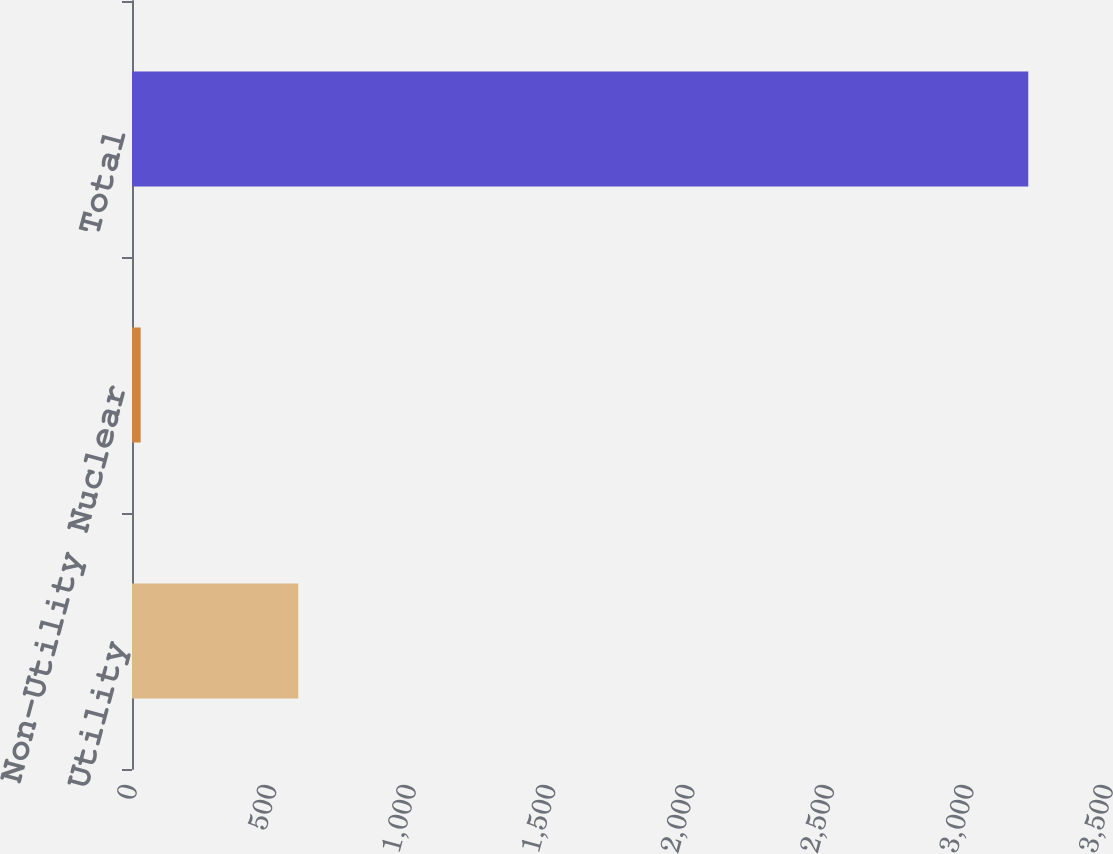Convert chart to OTSL. <chart><loc_0><loc_0><loc_500><loc_500><bar_chart><fcel>Utility<fcel>Non-Utility Nuclear<fcel>Total<nl><fcel>596<fcel>31<fcel>3214<nl></chart> 